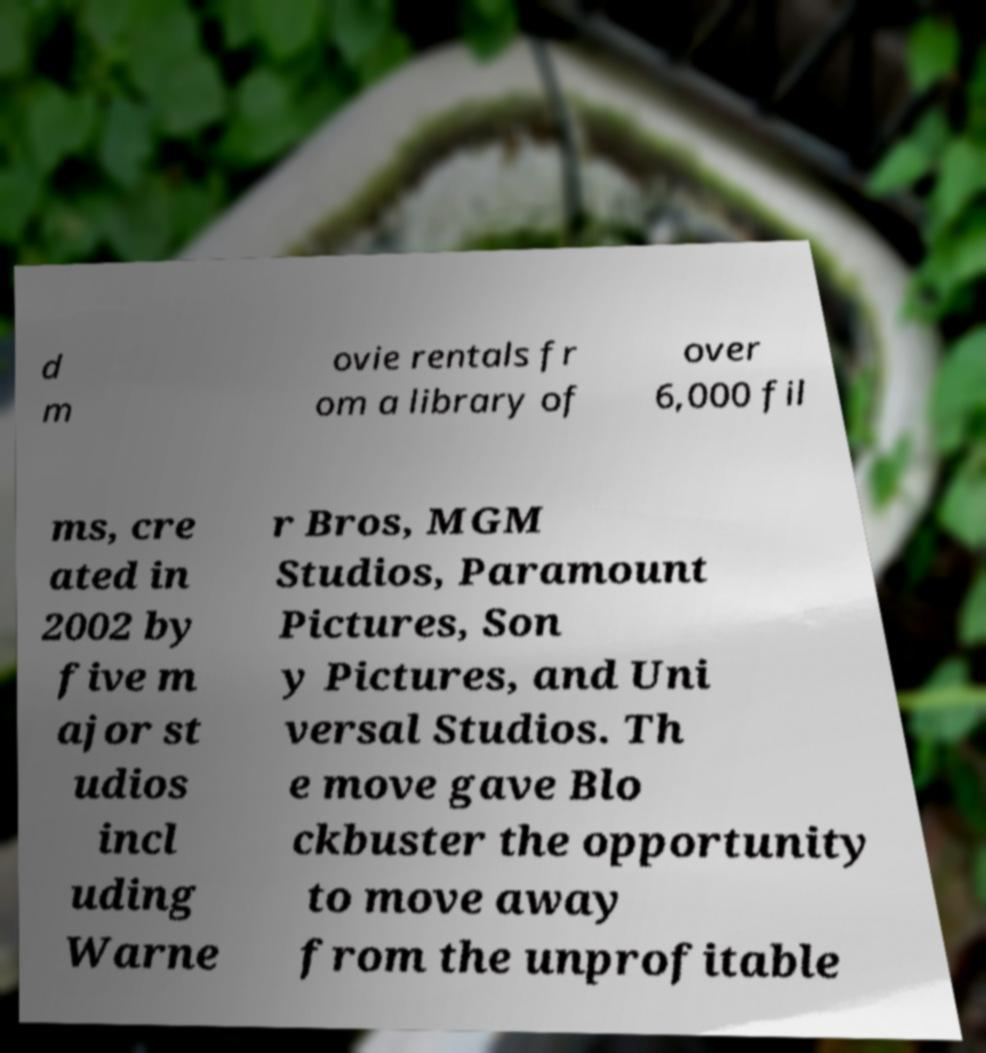Can you accurately transcribe the text from the provided image for me? d m ovie rentals fr om a library of over 6,000 fil ms, cre ated in 2002 by five m ajor st udios incl uding Warne r Bros, MGM Studios, Paramount Pictures, Son y Pictures, and Uni versal Studios. Th e move gave Blo ckbuster the opportunity to move away from the unprofitable 